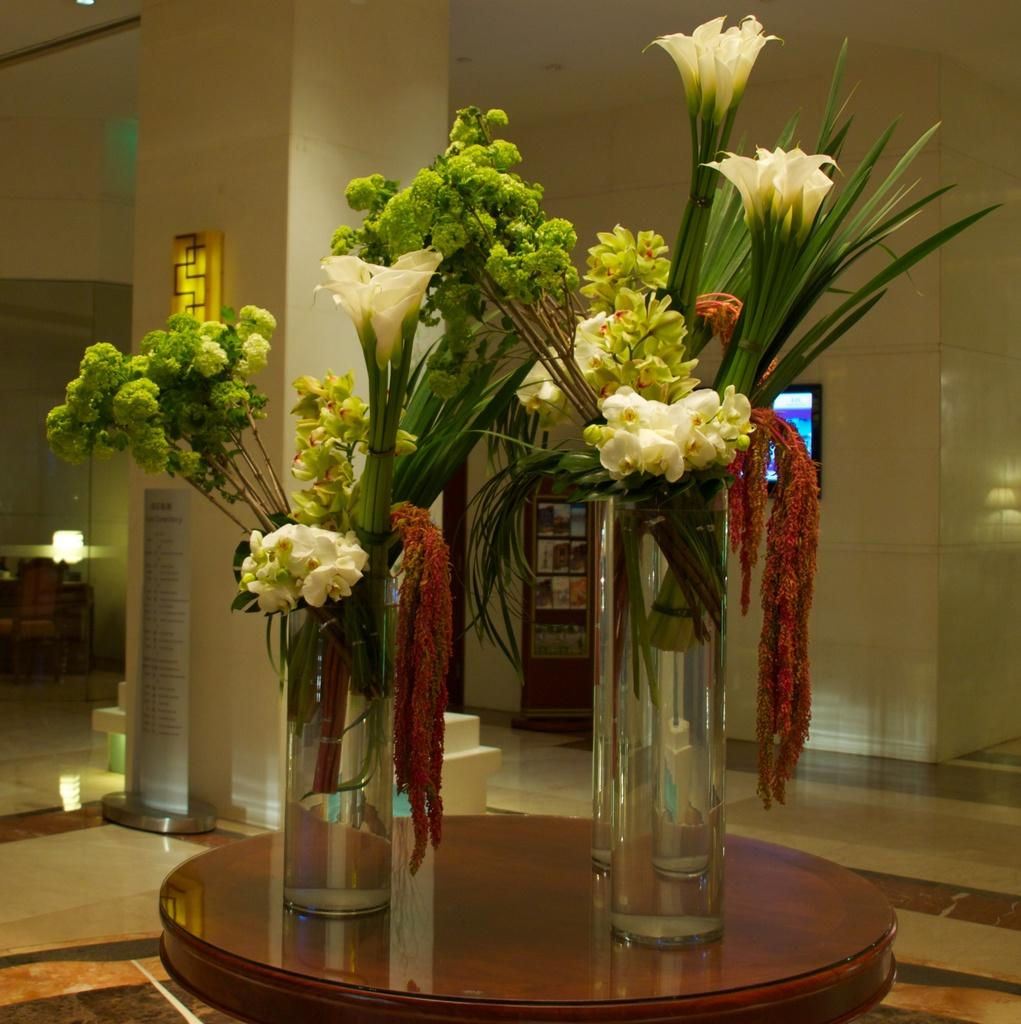What type of plants are in the glass in the image? There are flower plants in a glass in the image. Where is the glass with flower plants located? The glass with flower plants is placed on a table. What electronic device is visible in the image? There is a monitor visible in the image. What type of illumination is present in the image? Lights are present in the image. What is the representative doing with their arm in the image? There is no representative or arm present in the image. 